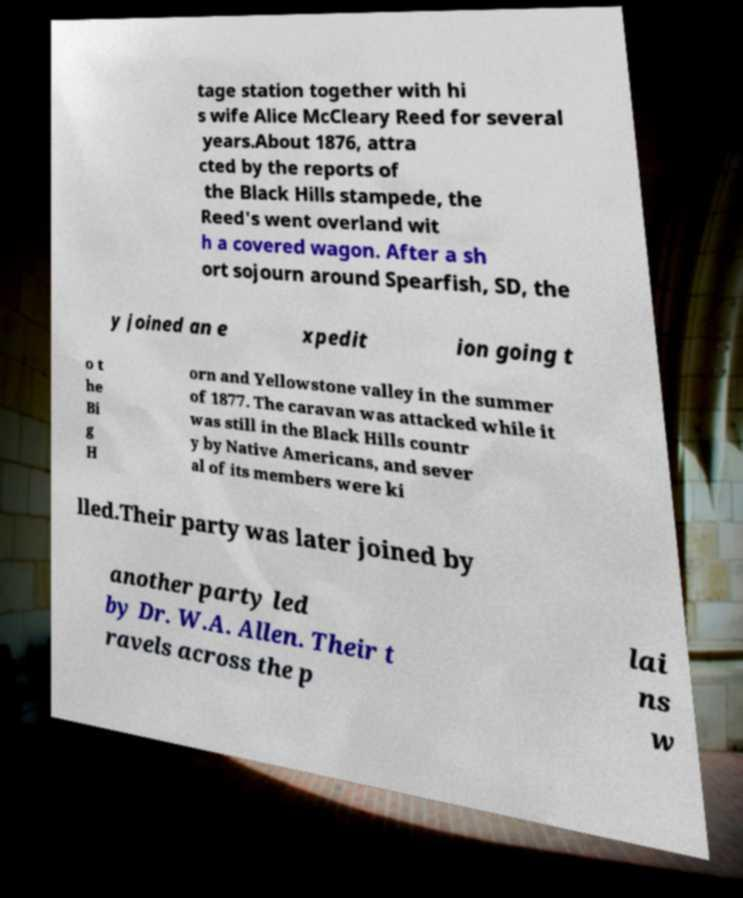For documentation purposes, I need the text within this image transcribed. Could you provide that? tage station together with hi s wife Alice McCleary Reed for several years.About 1876, attra cted by the reports of the Black Hills stampede, the Reed's went overland wit h a covered wagon. After a sh ort sojourn around Spearfish, SD, the y joined an e xpedit ion going t o t he Bi g H orn and Yellowstone valley in the summer of 1877. The caravan was attacked while it was still in the Black Hills countr y by Native Americans, and sever al of its members were ki lled.Their party was later joined by another party led by Dr. W.A. Allen. Their t ravels across the p lai ns w 